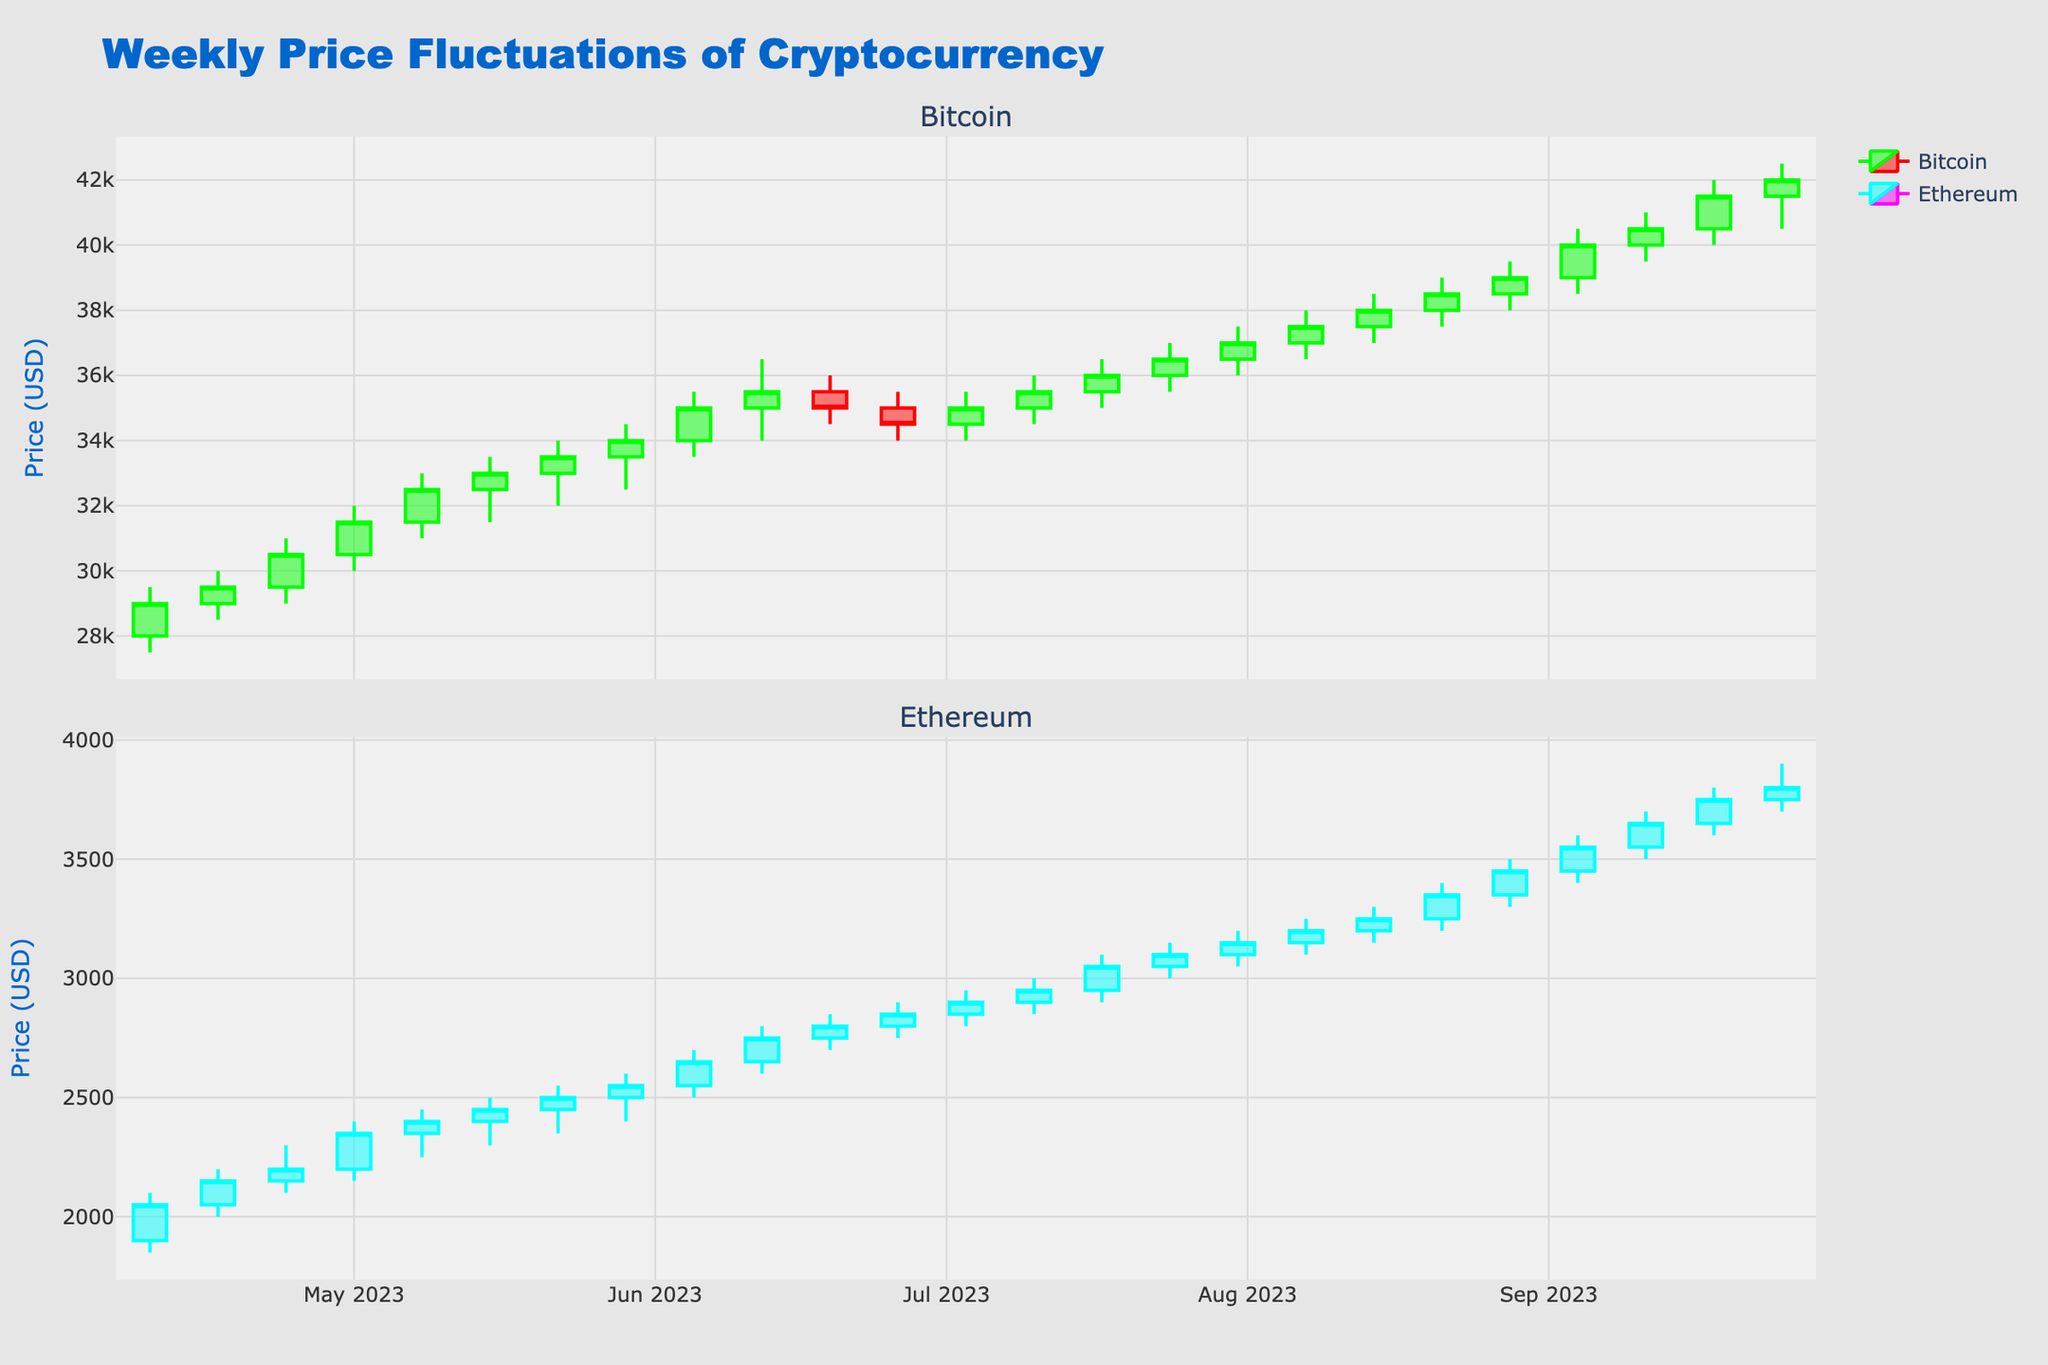Which cryptocurrency experienced the highest closing price in the given period? By inspecting the figure, you can identify that the highest closing price for Bitcoin was $42000 and for Ethereum was $3900. Between these, Bitcoin’s closing price is higher.
Answer: Bitcoin What is the general trend of Bitcoin prices over the six months? By observing the Bitcoin candlestick plot, it's apparent that the prices generally increase over time with fluctuations, showing an upward trend.
Answer: Upward trend During which week did Ethereum reach its highest high price? The candlestick plot shows that Ethereum reached its highest high price of $3900 on the week of September 25, 2023.
Answer: Week of September 25, 2023 Compare the closing prices of Bitcoin and Ethereum during the week of June 26, 2023. Which one was higher? For the week of June 26, 2023, the closing price for Bitcoin was $34500, and for Ethereum, it was $2850. Bitcoin's closing price is higher than Ethereum's.
Answer: Bitcoin What is the difference in closing prices between Bitcoin and Ethereum at the end of the six-month period? As of the last week in the data (September 25, 2023), the closing price for Bitcoin was $42000 and for Ethereum was $3800. The difference is $42000 - $3800, which equals $38200.
Answer: $38200 Which cryptocurrency had more volatility, as indicated by larger candlestick ranges, during the period? By comparing the lengths of the candlesticks for both Bitcoin and Ethereum, Bitcoin generally shows larger candlestick ranges, indicating more volatility.
Answer: Bitcoin What is the average closing price of Ethereum over the six-month period? To calculate this, sum all the closing prices of Ethereum and divide by the number of weeks: (2050+2150+2200+2350+2400+2450+2500+2550+2650+2750+2800+2850+2900+2950+3050+3100+3150+3200+3250+3350+3450+3550+3650+3750 + 3800) / 24 = 2825
Answer: 2825 Which week did Bitcoin experience a significant drop in price from the opening to the closing of that week? By inspecting the candlestick chart for weeks where the price dropped, it becomes apparent that during the week of June 26, 2023, Bitcoin opened at $35000 and closed at $34500, indicating a drop.
Answer: Week of June 26, 2023 Was there any week where both Bitcoin and Ethereum closed higher than their respective opening prices? If so, identify one. Observing the plots for both Bitcoin and Ethereum, both cryptocurrencies closed higher than they opened in the week of July 10, 2023 (Bitcoin: opened $34500, closed $35000; Ethereum: opened $2850, closed $2900).
Answer: Week of July 10, 2023 